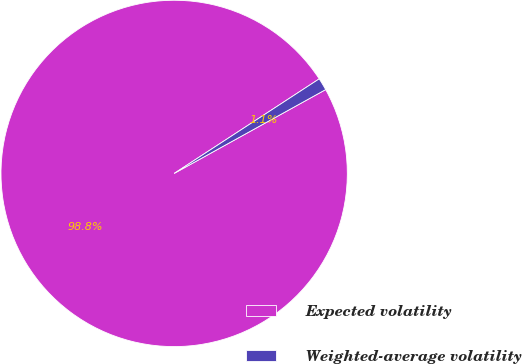<chart> <loc_0><loc_0><loc_500><loc_500><pie_chart><fcel>Expected volatility<fcel>Weighted-average volatility<nl><fcel>98.85%<fcel>1.15%<nl></chart> 